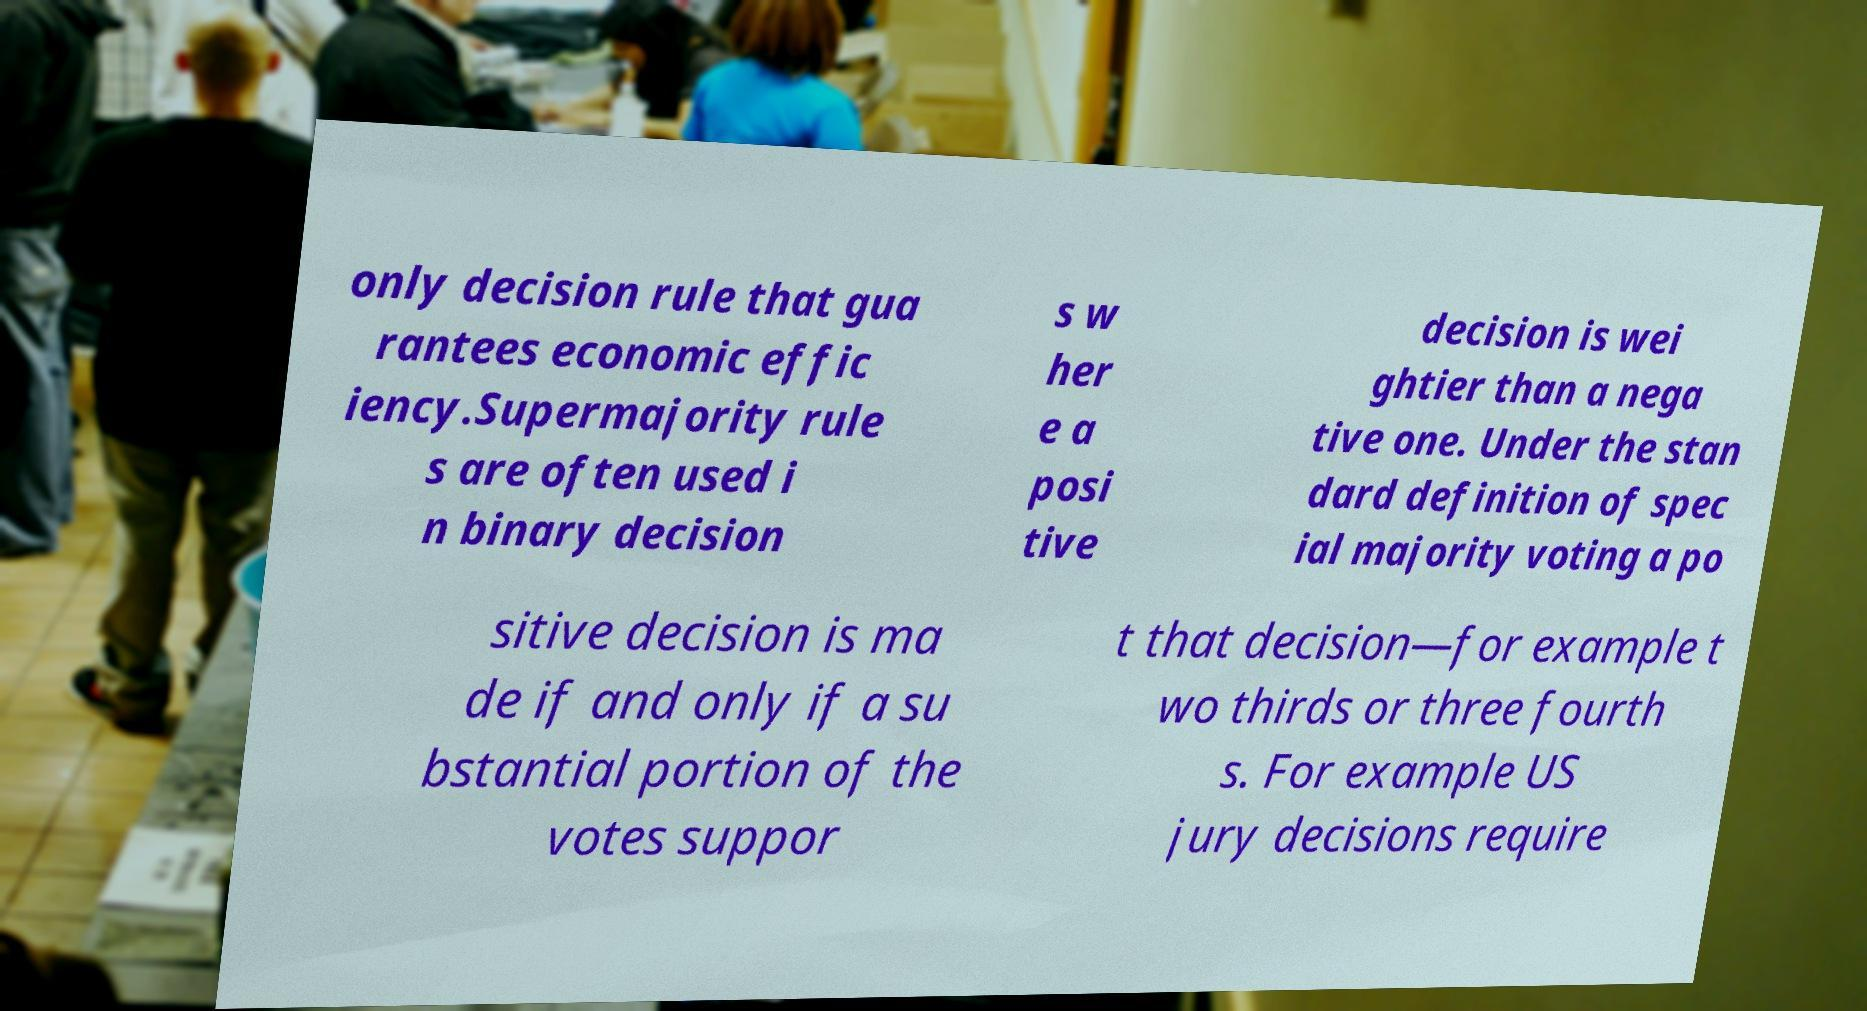Please identify and transcribe the text found in this image. only decision rule that gua rantees economic effic iency.Supermajority rule s are often used i n binary decision s w her e a posi tive decision is wei ghtier than a nega tive one. Under the stan dard definition of spec ial majority voting a po sitive decision is ma de if and only if a su bstantial portion of the votes suppor t that decision—for example t wo thirds or three fourth s. For example US jury decisions require 